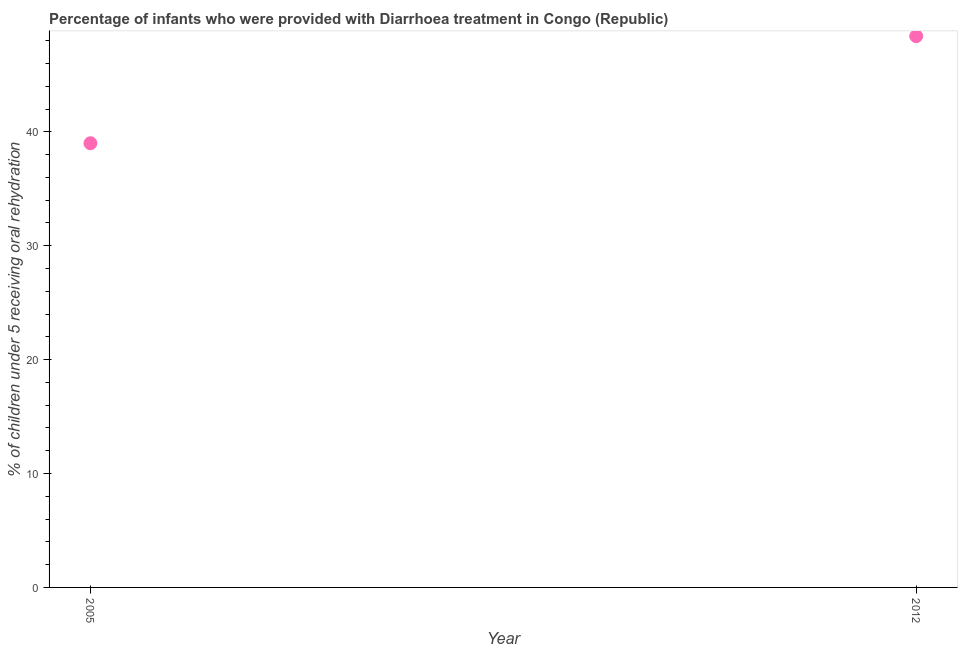What is the percentage of children who were provided with treatment diarrhoea in 2005?
Your response must be concise. 39. Across all years, what is the maximum percentage of children who were provided with treatment diarrhoea?
Give a very brief answer. 48.4. Across all years, what is the minimum percentage of children who were provided with treatment diarrhoea?
Offer a terse response. 39. In which year was the percentage of children who were provided with treatment diarrhoea maximum?
Your answer should be very brief. 2012. What is the sum of the percentage of children who were provided with treatment diarrhoea?
Your answer should be very brief. 87.4. What is the difference between the percentage of children who were provided with treatment diarrhoea in 2005 and 2012?
Keep it short and to the point. -9.4. What is the average percentage of children who were provided with treatment diarrhoea per year?
Make the answer very short. 43.7. What is the median percentage of children who were provided with treatment diarrhoea?
Provide a succinct answer. 43.7. What is the ratio of the percentage of children who were provided with treatment diarrhoea in 2005 to that in 2012?
Your response must be concise. 0.81. In how many years, is the percentage of children who were provided with treatment diarrhoea greater than the average percentage of children who were provided with treatment diarrhoea taken over all years?
Give a very brief answer. 1. How many dotlines are there?
Your response must be concise. 1. Does the graph contain grids?
Your answer should be very brief. No. What is the title of the graph?
Give a very brief answer. Percentage of infants who were provided with Diarrhoea treatment in Congo (Republic). What is the label or title of the X-axis?
Your response must be concise. Year. What is the label or title of the Y-axis?
Provide a short and direct response. % of children under 5 receiving oral rehydration. What is the % of children under 5 receiving oral rehydration in 2012?
Ensure brevity in your answer.  48.4. What is the ratio of the % of children under 5 receiving oral rehydration in 2005 to that in 2012?
Make the answer very short. 0.81. 